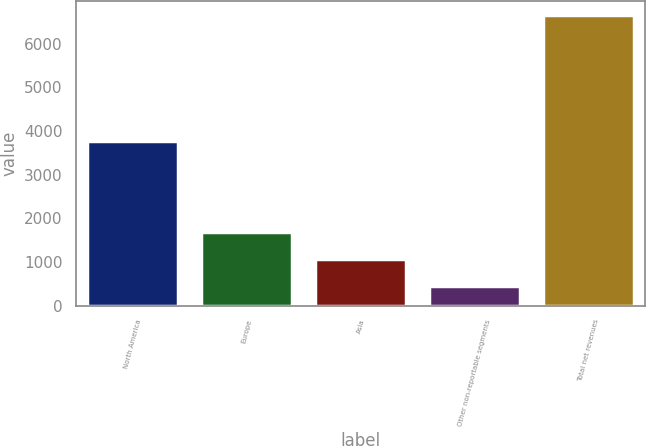Convert chart. <chart><loc_0><loc_0><loc_500><loc_500><bar_chart><fcel>North America<fcel>Europe<fcel>Asia<fcel>Other non-reportable segments<fcel>Total net revenues<nl><fcel>3783<fcel>1685.68<fcel>1064.79<fcel>443.9<fcel>6652.8<nl></chart> 